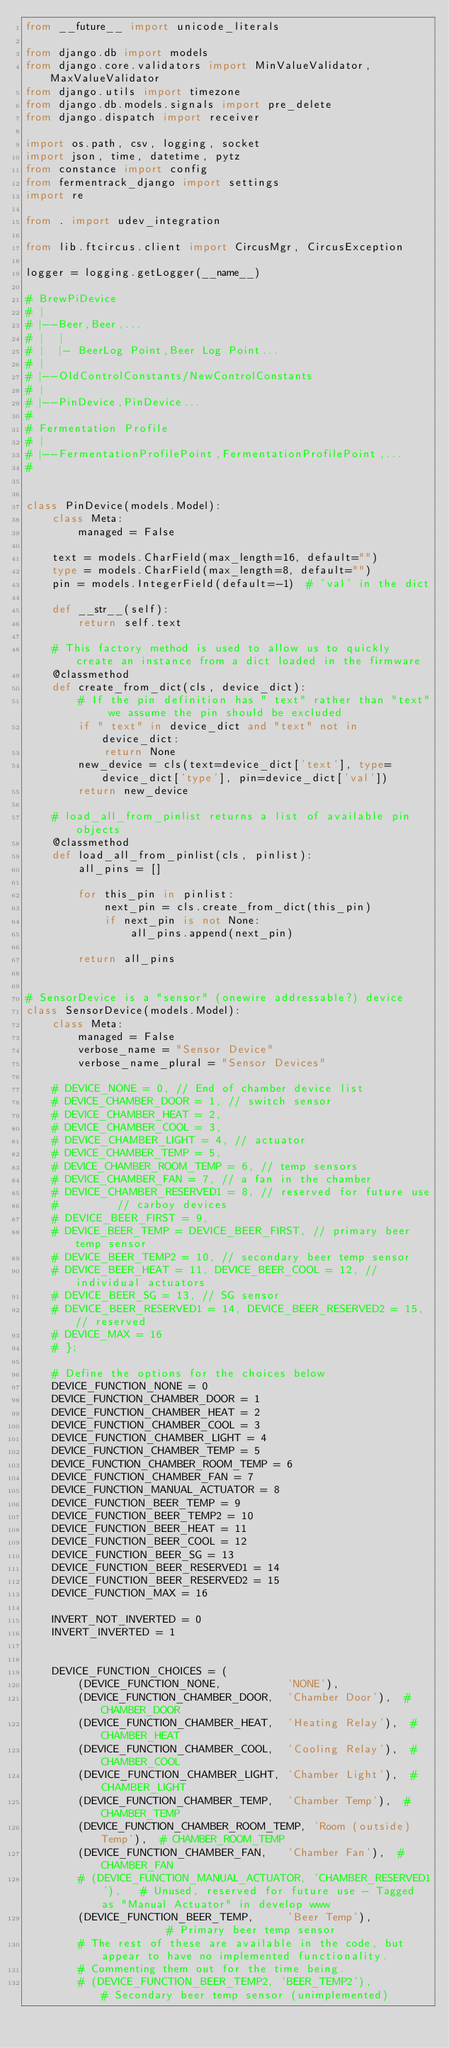Convert code to text. <code><loc_0><loc_0><loc_500><loc_500><_Python_>from __future__ import unicode_literals

from django.db import models
from django.core.validators import MinValueValidator, MaxValueValidator
from django.utils import timezone
from django.db.models.signals import pre_delete
from django.dispatch import receiver

import os.path, csv, logging, socket
import json, time, datetime, pytz
from constance import config
from fermentrack_django import settings
import re

from . import udev_integration

from lib.ftcircus.client import CircusMgr, CircusException

logger = logging.getLogger(__name__)

# BrewPiDevice
# |
# |--Beer,Beer,...
# |  |
# |  |- BeerLog Point,Beer Log Point...
# |
# |--OldControlConstants/NewControlConstants
# |
# |--PinDevice,PinDevice...
#
# Fermentation Profile
# |
# |--FermentationProfilePoint,FermentationProfilePoint,...
#


class PinDevice(models.Model):
    class Meta:
        managed = False

    text = models.CharField(max_length=16, default="")
    type = models.CharField(max_length=8, default="")
    pin = models.IntegerField(default=-1)  # 'val' in the dict

    def __str__(self):
        return self.text

    # This factory method is used to allow us to quickly create an instance from a dict loaded in the firmware
    @classmethod
    def create_from_dict(cls, device_dict):
        # If the pin definition has " text" rather than "text" we assume the pin should be excluded
        if " text" in device_dict and "text" not in device_dict:
            return None
        new_device = cls(text=device_dict['text'], type=device_dict['type'], pin=device_dict['val'])
        return new_device

    # load_all_from_pinlist returns a list of available pin objects
    @classmethod
    def load_all_from_pinlist(cls, pinlist):
        all_pins = []

        for this_pin in pinlist:
            next_pin = cls.create_from_dict(this_pin)
            if next_pin is not None:
                all_pins.append(next_pin)

        return all_pins


# SensorDevice is a "sensor" (onewire addressable?) device
class SensorDevice(models.Model):
    class Meta:
        managed = False
        verbose_name = "Sensor Device"
        verbose_name_plural = "Sensor Devices"

    # DEVICE_NONE = 0, // End of chamber device list
    # DEVICE_CHAMBER_DOOR = 1, // switch sensor
    # DEVICE_CHAMBER_HEAT = 2,
    # DEVICE_CHAMBER_COOL = 3,
    # DEVICE_CHAMBER_LIGHT = 4, // actuator
    # DEVICE_CHAMBER_TEMP = 5,
    # DEVICE_CHAMBER_ROOM_TEMP = 6, // temp sensors
    # DEVICE_CHAMBER_FAN = 7, // a fan in the chamber
    # DEVICE_CHAMBER_RESERVED1 = 8, // reserved for future use
    #         // carboy devices
    # DEVICE_BEER_FIRST = 9,
    # DEVICE_BEER_TEMP = DEVICE_BEER_FIRST, // primary beer temp sensor
    # DEVICE_BEER_TEMP2 = 10, // secondary beer temp sensor
    # DEVICE_BEER_HEAT = 11, DEVICE_BEER_COOL = 12, // individual actuators
    # DEVICE_BEER_SG = 13, // SG sensor
    # DEVICE_BEER_RESERVED1 = 14, DEVICE_BEER_RESERVED2 = 15, // reserved
    # DEVICE_MAX = 16
    # };

    # Define the options for the choices below
    DEVICE_FUNCTION_NONE = 0
    DEVICE_FUNCTION_CHAMBER_DOOR = 1
    DEVICE_FUNCTION_CHAMBER_HEAT = 2
    DEVICE_FUNCTION_CHAMBER_COOL = 3
    DEVICE_FUNCTION_CHAMBER_LIGHT = 4
    DEVICE_FUNCTION_CHAMBER_TEMP = 5
    DEVICE_FUNCTION_CHAMBER_ROOM_TEMP = 6
    DEVICE_FUNCTION_CHAMBER_FAN = 7
    DEVICE_FUNCTION_MANUAL_ACTUATOR = 8
    DEVICE_FUNCTION_BEER_TEMP = 9
    DEVICE_FUNCTION_BEER_TEMP2 = 10
    DEVICE_FUNCTION_BEER_HEAT = 11
    DEVICE_FUNCTION_BEER_COOL = 12
    DEVICE_FUNCTION_BEER_SG = 13
    DEVICE_FUNCTION_BEER_RESERVED1 = 14
    DEVICE_FUNCTION_BEER_RESERVED2 = 15
    DEVICE_FUNCTION_MAX = 16

    INVERT_NOT_INVERTED = 0
    INVERT_INVERTED = 1


    DEVICE_FUNCTION_CHOICES = (
        (DEVICE_FUNCTION_NONE,          'NONE'),
        (DEVICE_FUNCTION_CHAMBER_DOOR,  'Chamber Door'),  # CHAMBER_DOOR
        (DEVICE_FUNCTION_CHAMBER_HEAT,  'Heating Relay'),  # CHAMBER_HEAT
        (DEVICE_FUNCTION_CHAMBER_COOL,  'Cooling Relay'),  # CHAMBER_COOL
        (DEVICE_FUNCTION_CHAMBER_LIGHT, 'Chamber Light'),  # CHAMBER_LIGHT
        (DEVICE_FUNCTION_CHAMBER_TEMP,  'Chamber Temp'),  # CHAMBER_TEMP
        (DEVICE_FUNCTION_CHAMBER_ROOM_TEMP, 'Room (outside) Temp'),  # CHAMBER_ROOM_TEMP
        (DEVICE_FUNCTION_CHAMBER_FAN,   'Chamber Fan'),  # CHAMBER_FAN
        # (DEVICE_FUNCTION_MANUAL_ACTUATOR, 'CHAMBER_RESERVED1'),   # Unused, reserved for future use - Tagged as "Manual Actuator" in develop www
        (DEVICE_FUNCTION_BEER_TEMP,     'Beer Temp'),           # Primary beer temp sensor
        # The rest of these are available in the code, but appear to have no implemented functionality.
        # Commenting them out for the time being.
        # (DEVICE_FUNCTION_BEER_TEMP2, 'BEER_TEMP2'),         # Secondary beer temp sensor (unimplemented)</code> 